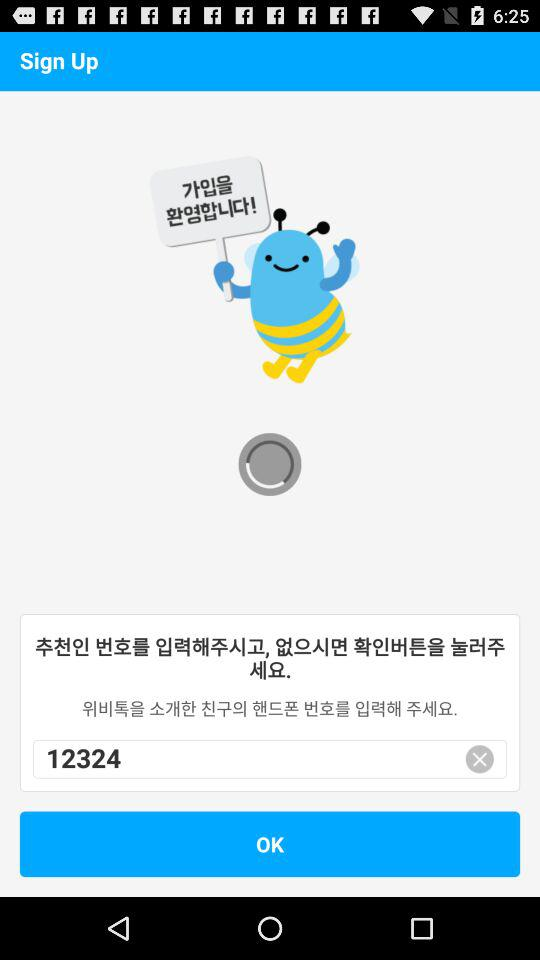What phone number is displayed? The phone number is +1 4153402255. 